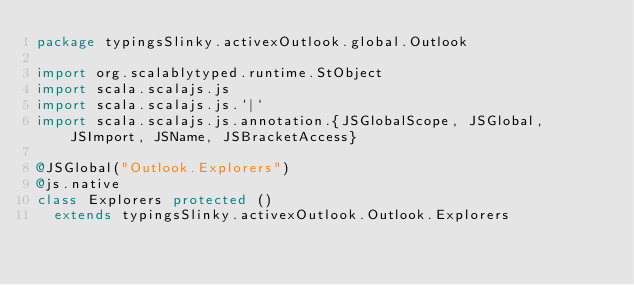Convert code to text. <code><loc_0><loc_0><loc_500><loc_500><_Scala_>package typingsSlinky.activexOutlook.global.Outlook

import org.scalablytyped.runtime.StObject
import scala.scalajs.js
import scala.scalajs.js.`|`
import scala.scalajs.js.annotation.{JSGlobalScope, JSGlobal, JSImport, JSName, JSBracketAccess}

@JSGlobal("Outlook.Explorers")
@js.native
class Explorers protected ()
  extends typingsSlinky.activexOutlook.Outlook.Explorers
</code> 